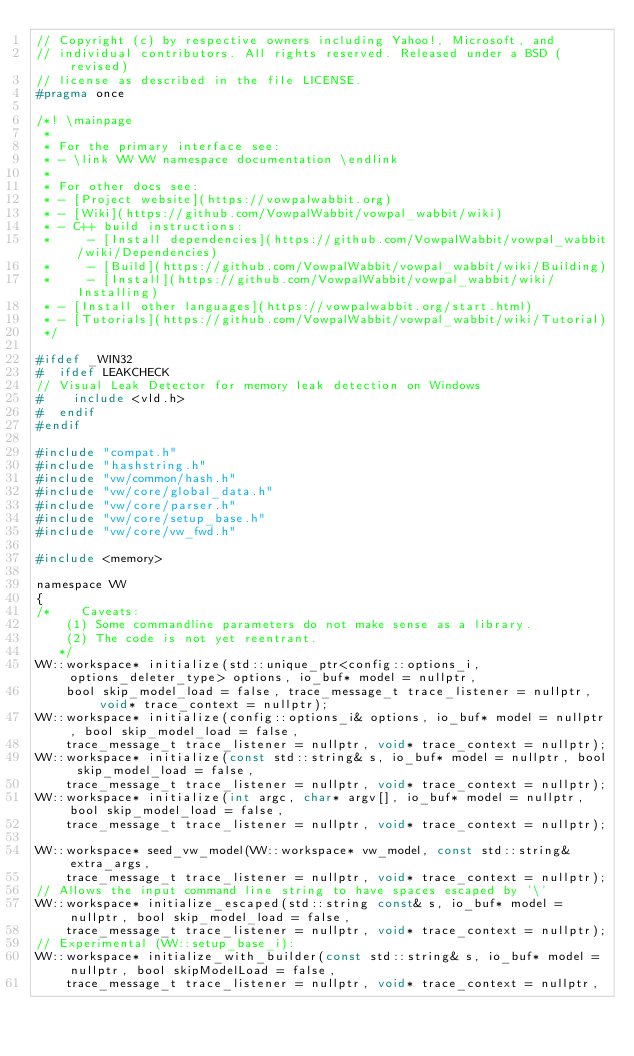Convert code to text. <code><loc_0><loc_0><loc_500><loc_500><_C_>// Copyright (c) by respective owners including Yahoo!, Microsoft, and
// individual contributors. All rights reserved. Released under a BSD (revised)
// license as described in the file LICENSE.
#pragma once

/*! \mainpage
 *
 * For the primary interface see:
 * - \link VW VW namespace documentation \endlink
 *
 * For other docs see:
 * - [Project website](https://vowpalwabbit.org)
 * - [Wiki](https://github.com/VowpalWabbit/vowpal_wabbit/wiki)
 * - C++ build instructions:
 *     - [Install dependencies](https://github.com/VowpalWabbit/vowpal_wabbit/wiki/Dependencies)
 *     - [Build](https://github.com/VowpalWabbit/vowpal_wabbit/wiki/Building)
 *     - [Install](https://github.com/VowpalWabbit/vowpal_wabbit/wiki/Installing)
 * - [Install other languages](https://vowpalwabbit.org/start.html)
 * - [Tutorials](https://github.com/VowpalWabbit/vowpal_wabbit/wiki/Tutorial)
 */

#ifdef _WIN32
#  ifdef LEAKCHECK
// Visual Leak Detector for memory leak detection on Windows
#    include <vld.h>
#  endif
#endif

#include "compat.h"
#include "hashstring.h"
#include "vw/common/hash.h"
#include "vw/core/global_data.h"
#include "vw/core/parser.h"
#include "vw/core/setup_base.h"
#include "vw/core/vw_fwd.h"

#include <memory>

namespace VW
{
/*    Caveats:
    (1) Some commandline parameters do not make sense as a library.
    (2) The code is not yet reentrant.
   */
VW::workspace* initialize(std::unique_ptr<config::options_i, options_deleter_type> options, io_buf* model = nullptr,
    bool skip_model_load = false, trace_message_t trace_listener = nullptr, void* trace_context = nullptr);
VW::workspace* initialize(config::options_i& options, io_buf* model = nullptr, bool skip_model_load = false,
    trace_message_t trace_listener = nullptr, void* trace_context = nullptr);
VW::workspace* initialize(const std::string& s, io_buf* model = nullptr, bool skip_model_load = false,
    trace_message_t trace_listener = nullptr, void* trace_context = nullptr);
VW::workspace* initialize(int argc, char* argv[], io_buf* model = nullptr, bool skip_model_load = false,
    trace_message_t trace_listener = nullptr, void* trace_context = nullptr);

VW::workspace* seed_vw_model(VW::workspace* vw_model, const std::string& extra_args,
    trace_message_t trace_listener = nullptr, void* trace_context = nullptr);
// Allows the input command line string to have spaces escaped by '\'
VW::workspace* initialize_escaped(std::string const& s, io_buf* model = nullptr, bool skip_model_load = false,
    trace_message_t trace_listener = nullptr, void* trace_context = nullptr);
// Experimental (VW::setup_base_i):
VW::workspace* initialize_with_builder(const std::string& s, io_buf* model = nullptr, bool skipModelLoad = false,
    trace_message_t trace_listener = nullptr, void* trace_context = nullptr,</code> 